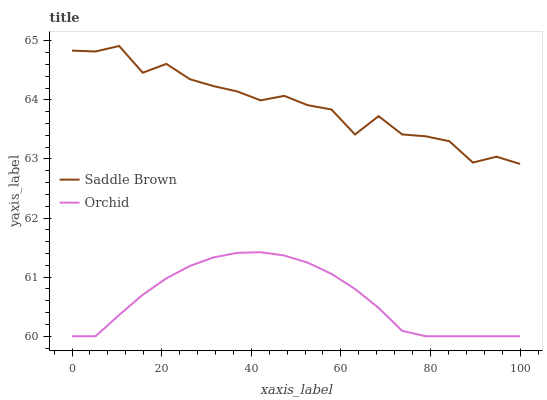Does Orchid have the minimum area under the curve?
Answer yes or no. Yes. Does Saddle Brown have the maximum area under the curve?
Answer yes or no. Yes. Does Orchid have the maximum area under the curve?
Answer yes or no. No. Is Orchid the smoothest?
Answer yes or no. Yes. Is Saddle Brown the roughest?
Answer yes or no. Yes. Is Orchid the roughest?
Answer yes or no. No. Does Orchid have the lowest value?
Answer yes or no. Yes. Does Saddle Brown have the highest value?
Answer yes or no. Yes. Does Orchid have the highest value?
Answer yes or no. No. Is Orchid less than Saddle Brown?
Answer yes or no. Yes. Is Saddle Brown greater than Orchid?
Answer yes or no. Yes. Does Orchid intersect Saddle Brown?
Answer yes or no. No. 